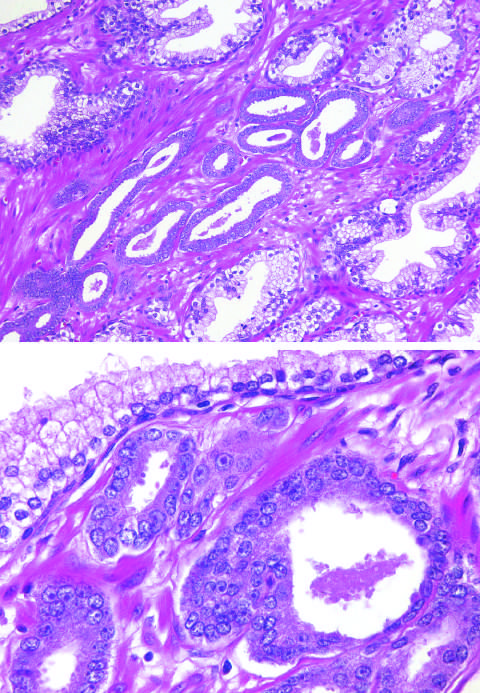what does higher magnification show with enlarged nuclei, prominent nucleoli, and dark cytoplasm, as compared with the larger, benign gland?
Answer the question using a single word or phrase. Small malignant glands 